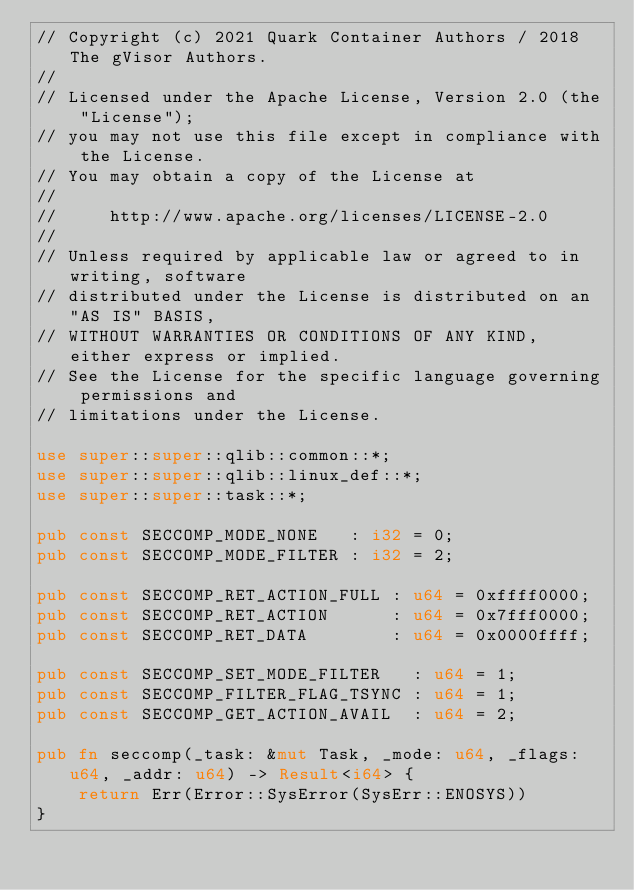<code> <loc_0><loc_0><loc_500><loc_500><_Rust_>// Copyright (c) 2021 Quark Container Authors / 2018 The gVisor Authors.
//
// Licensed under the Apache License, Version 2.0 (the "License");
// you may not use this file except in compliance with the License.
// You may obtain a copy of the License at
//
//     http://www.apache.org/licenses/LICENSE-2.0
//
// Unless required by applicable law or agreed to in writing, software
// distributed under the License is distributed on an "AS IS" BASIS,
// WITHOUT WARRANTIES OR CONDITIONS OF ANY KIND, either express or implied.
// See the License for the specific language governing permissions and
// limitations under the License.

use super::super::qlib::common::*;
use super::super::qlib::linux_def::*;
use super::super::task::*;

pub const SECCOMP_MODE_NONE   : i32 = 0;
pub const SECCOMP_MODE_FILTER : i32 = 2;

pub const SECCOMP_RET_ACTION_FULL : u64 = 0xffff0000;
pub const SECCOMP_RET_ACTION      : u64 = 0x7fff0000;
pub const SECCOMP_RET_DATA        : u64 = 0x0000ffff;

pub const SECCOMP_SET_MODE_FILTER   : u64 = 1;
pub const SECCOMP_FILTER_FLAG_TSYNC : u64 = 1;
pub const SECCOMP_GET_ACTION_AVAIL  : u64 = 2;

pub fn seccomp(_task: &mut Task, _mode: u64, _flags: u64, _addr: u64) -> Result<i64> {
    return Err(Error::SysError(SysErr::ENOSYS))
}</code> 